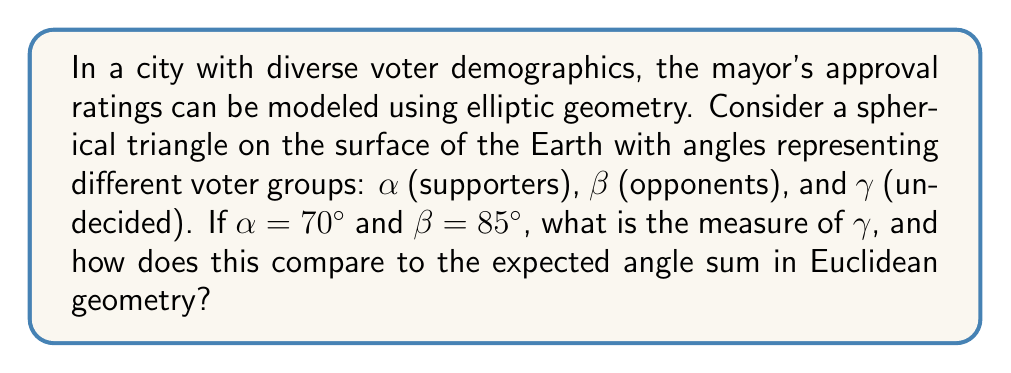Provide a solution to this math problem. 1) In elliptic geometry, specifically on a sphere, the sum of angles in a triangle is greater than 180°. The formula for the angle sum is:

   $$\alpha + \beta + \gamma = 180° + A$$

   Where $A$ is the area of the triangle relative to the total surface area of the sphere.

2) We are given $\alpha = 70°$ and $\beta = 85°$. Let's substitute these values:

   $$70° + 85° + \gamma = 180° + A$$

3) Simplify:

   $$155° + \gamma = 180° + A$$

4) Solve for $\gamma$:

   $$\gamma = 25° + A$$

5) In elliptic geometry, $A$ is always positive, so $\gamma > 25°$.

6) The exact value of $\gamma$ depends on the size of the triangle relative to the sphere, which we don't know. However, we can conclude that:

   $$\gamma > 25°$$

7) In Euclidean geometry, the angle sum would be exactly 180°, so $\gamma$ would be 25°.

8) The difference between elliptic and Euclidean geometry in this context represents the complexity of voter demographics that can't be captured by a flat model.
Answer: $\gamma > 25°$, exceeding the Euclidean expectation by $A$ degrees. 